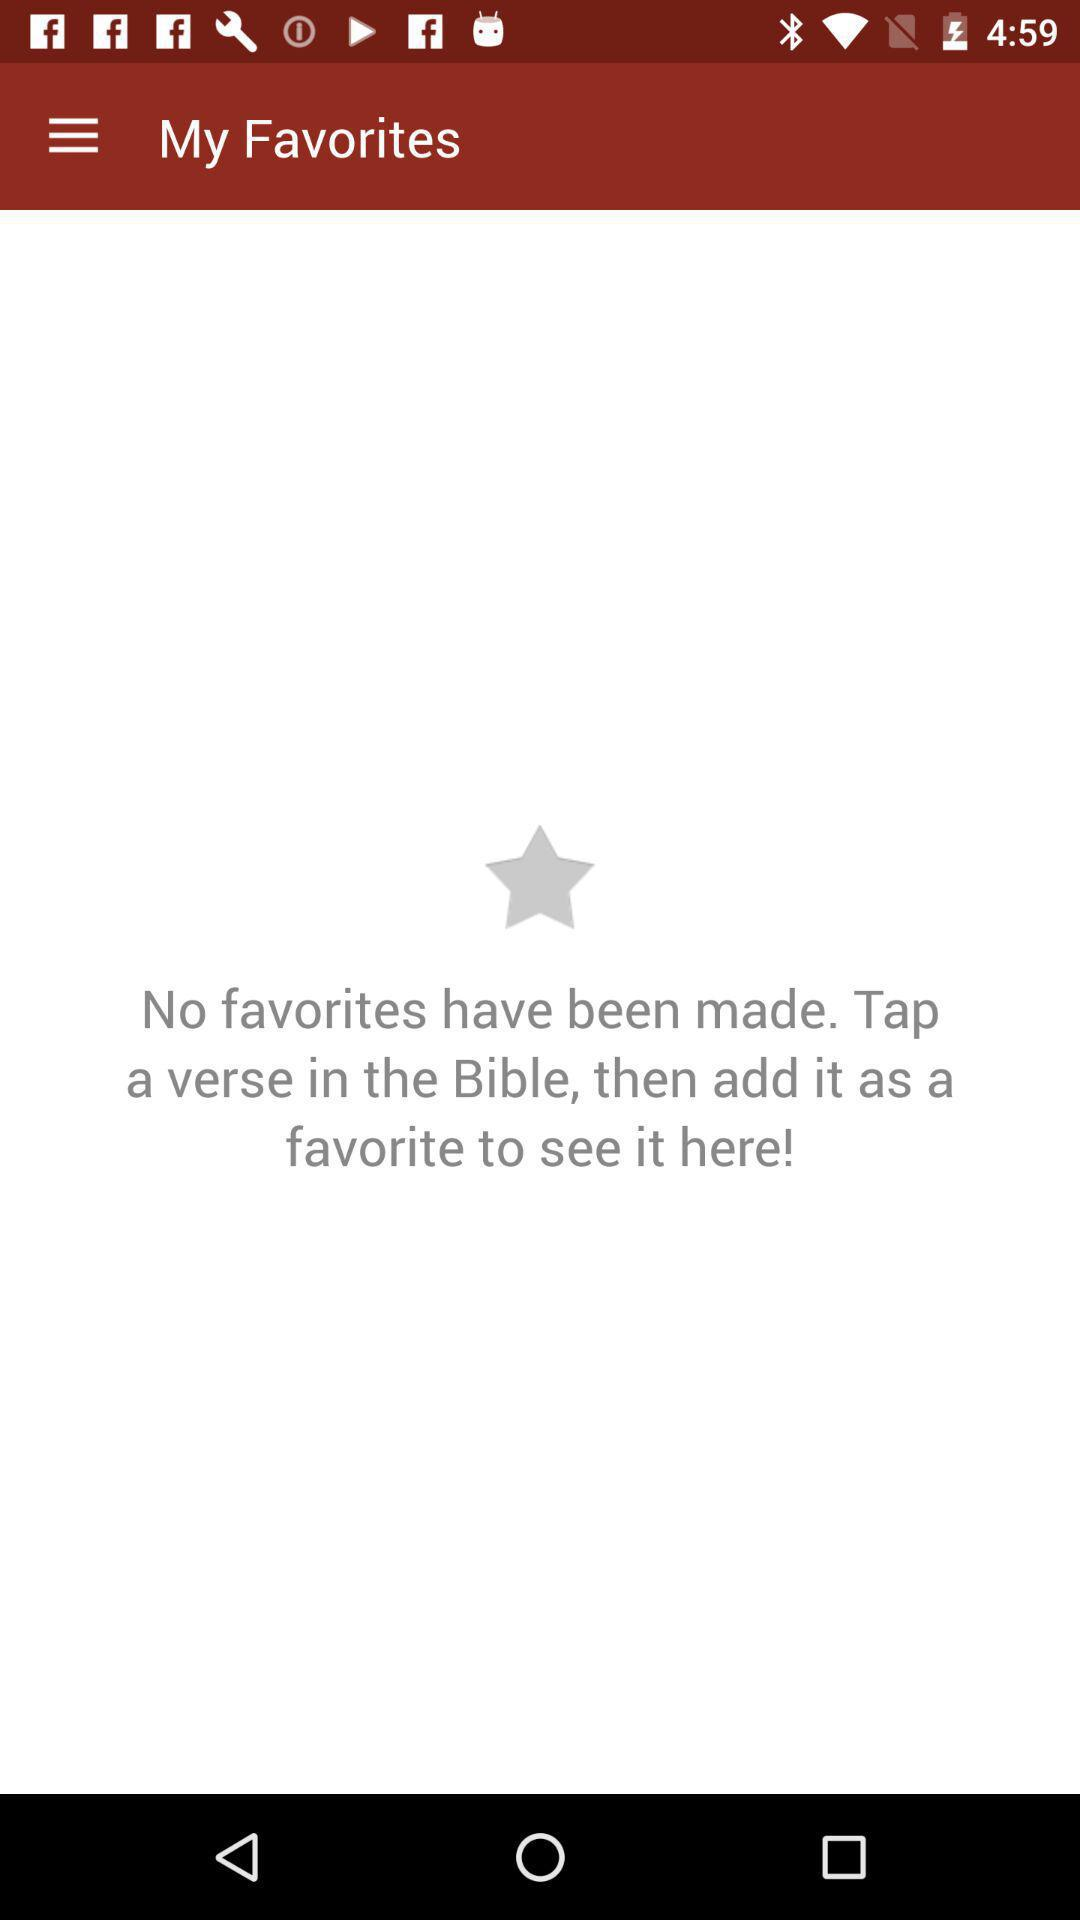Are there any favorites? There are no favorites. 